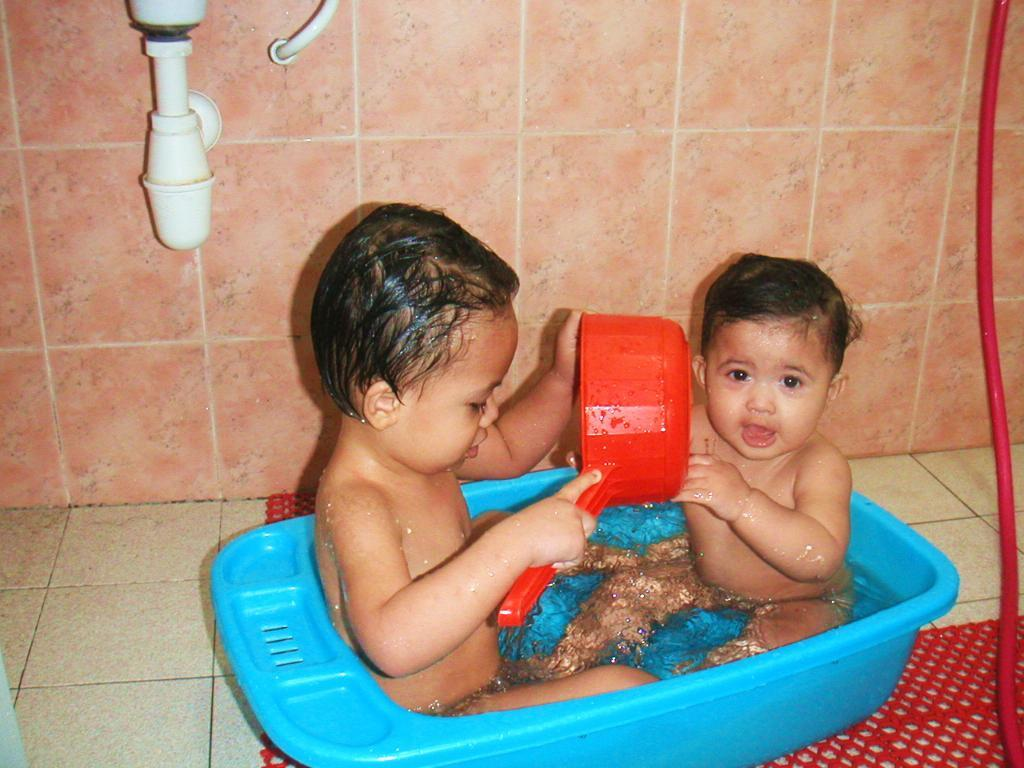How many kids are in the tub in the image? There are two kids in the tub in the image. What is in the tub with the kids? There is water in the tub. What can be seen in the background of the image? There is a wash basin and a wall in the background. What type of attention does the rabbit in the image require? There is no rabbit present in the image. What design elements can be seen on the wall in the image? The provided facts do not mention any design elements on the wall; only the presence of a wall is mentioned. 